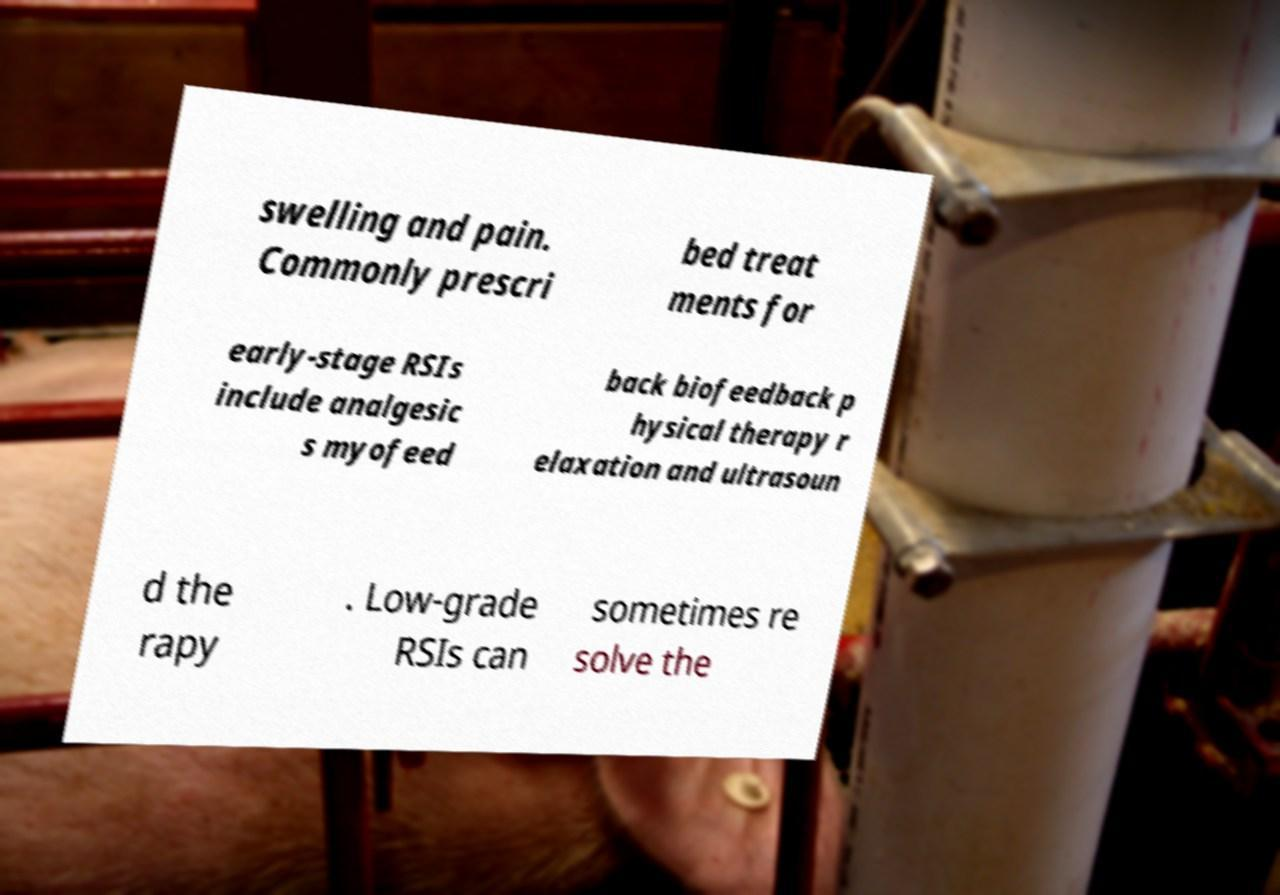Could you assist in decoding the text presented in this image and type it out clearly? swelling and pain. Commonly prescri bed treat ments for early-stage RSIs include analgesic s myofeed back biofeedback p hysical therapy r elaxation and ultrasoun d the rapy . Low-grade RSIs can sometimes re solve the 